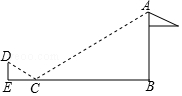As shown in the figure, in order to measure the height of the flagpole AB, Xiaofan placed a mirror at point C from the bottom of the flagpole B point 10.8. When Xiaofan walks to the point E, which is in the same straight line as BC, he can observe from the mirror. Go to point A on the top of the flagpole. Knowing that the height of point D where Xiaofan's eyes are from the ground is 1.6, CE = 2.7, then the height of the flagpole AB is () Choices: A: 6.4米 B: 7.2米 C: 8米 D: 9.6米 By employing the principles of geometric optics and the property of similar triangles, we can ascertain the height of the flagpole AB. By constructing the image visually, the congruent angles at point C (as angles DCH and ACH are equal) lead us to understand that triangles CDE and CAB are similar. This similarity reveals a proportional relationship between their sides, allowing us to establish the equation DE/AB = CE/CB. Substituting in the known values (1.6 for DE, 2.7 for CE, and 10.8 for CB), we can solve for AB, finding that the flagpole's height is precisely 6.4 meters. This mathematical journey not only provides us with the correct answer, which is 6.4 meters (Choice A), but also illustrates the harmonious blend of mathematics and the physical world, revealing how geometry can be applied to practical scenarios in our day-to-day experiences. 